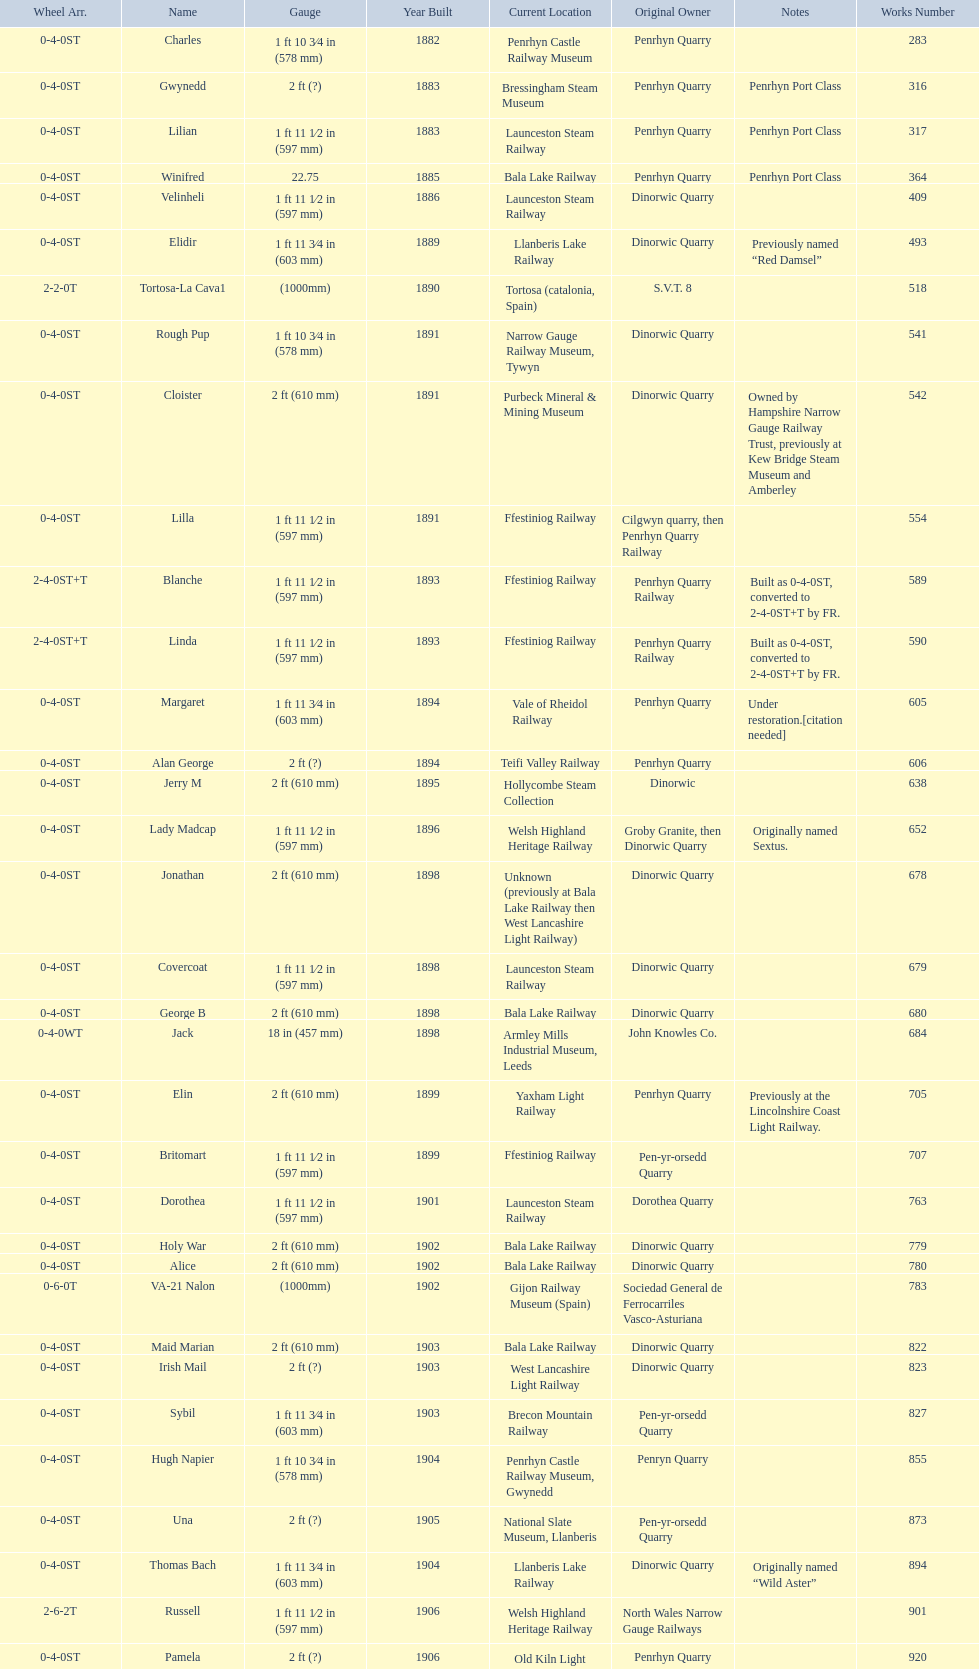Which original owner had the most locomotives? Penrhyn Quarry. 